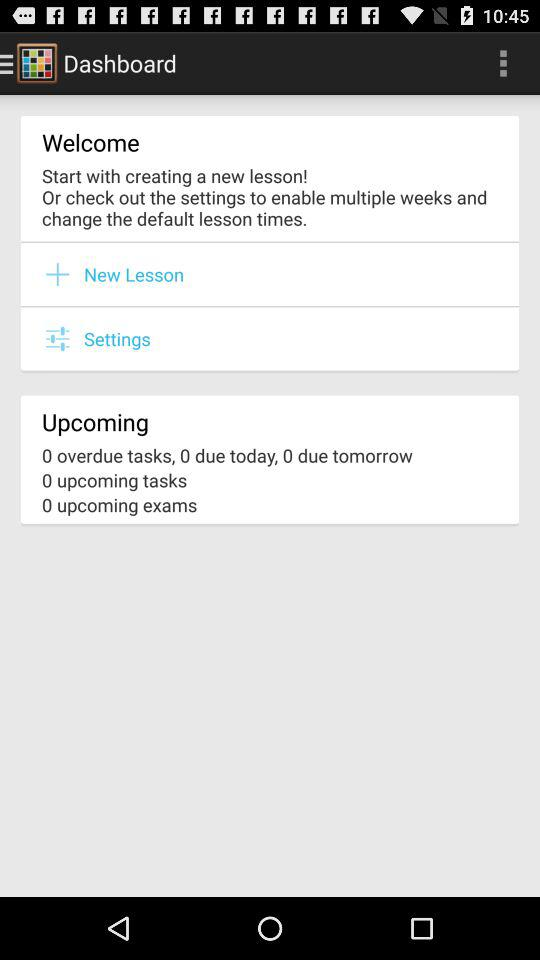Are there any upcoming tasks? There are no upcoming tasks. 